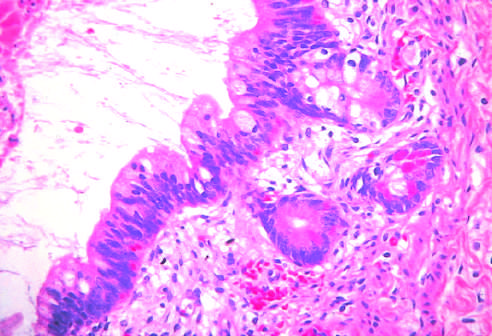what do testicular teratomas contain?
Answer the question using a single word or phrase. Mature cells from endodermal 